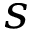<formula> <loc_0><loc_0><loc_500><loc_500>s</formula> 